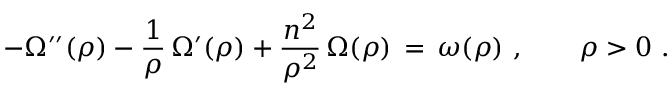<formula> <loc_0><loc_0><loc_500><loc_500>- \Omega ^ { \prime \prime } ( \rho ) - \frac { 1 } { \rho } \, \Omega ^ { \prime } ( \rho ) + \frac { n ^ { 2 } } { \rho ^ { 2 } } \, \Omega ( \rho ) \, = \, \omega ( \rho ) , \quad \rho > 0 .</formula> 